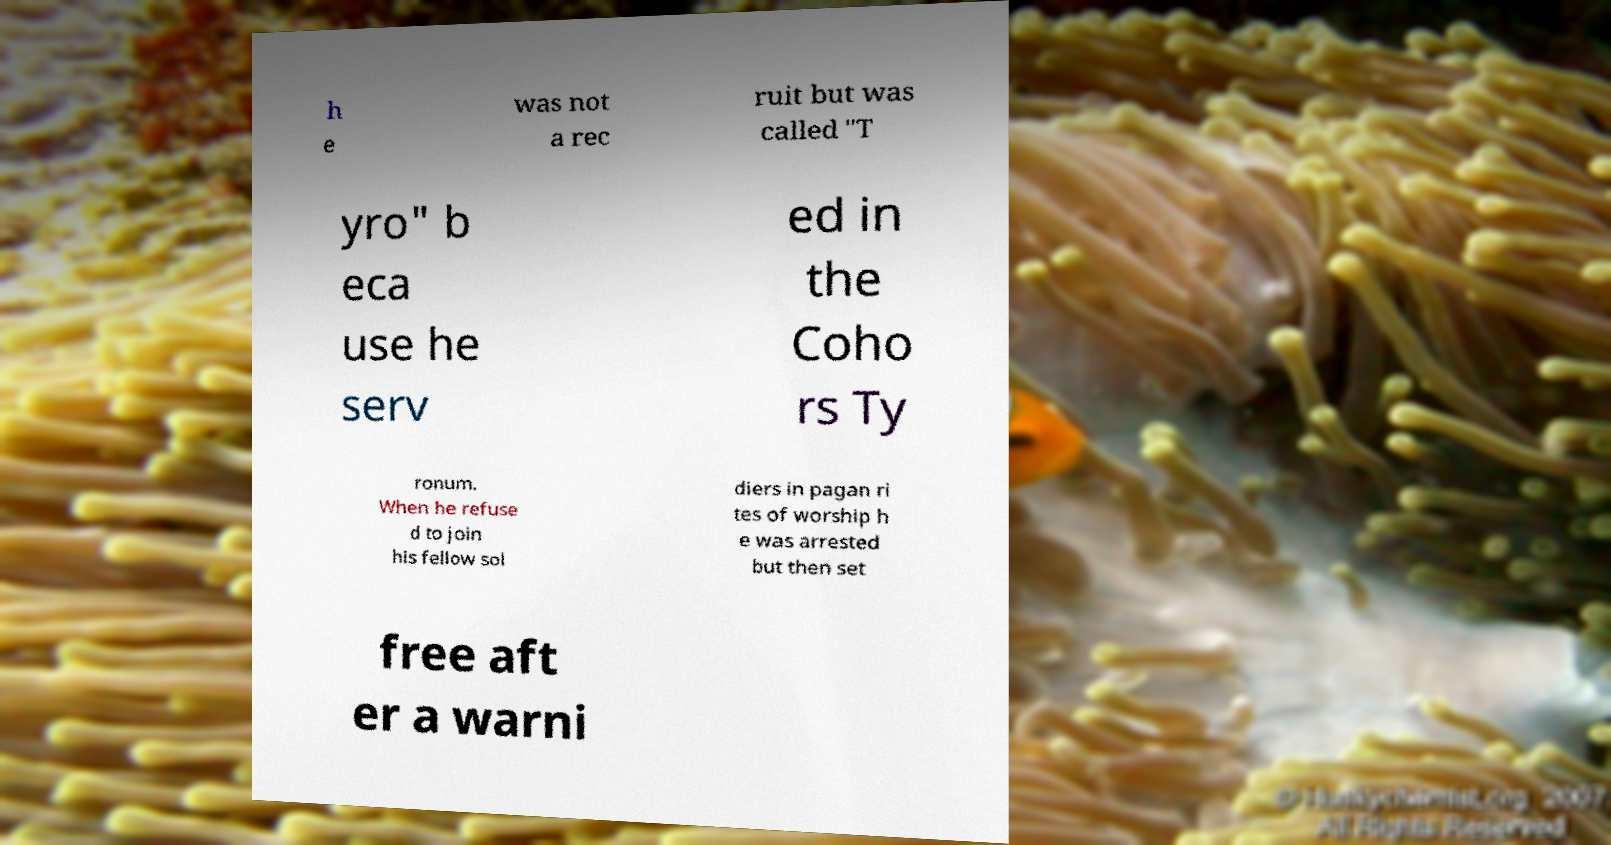There's text embedded in this image that I need extracted. Can you transcribe it verbatim? h e was not a rec ruit but was called "T yro" b eca use he serv ed in the Coho rs Ty ronum. When he refuse d to join his fellow sol diers in pagan ri tes of worship h e was arrested but then set free aft er a warni 